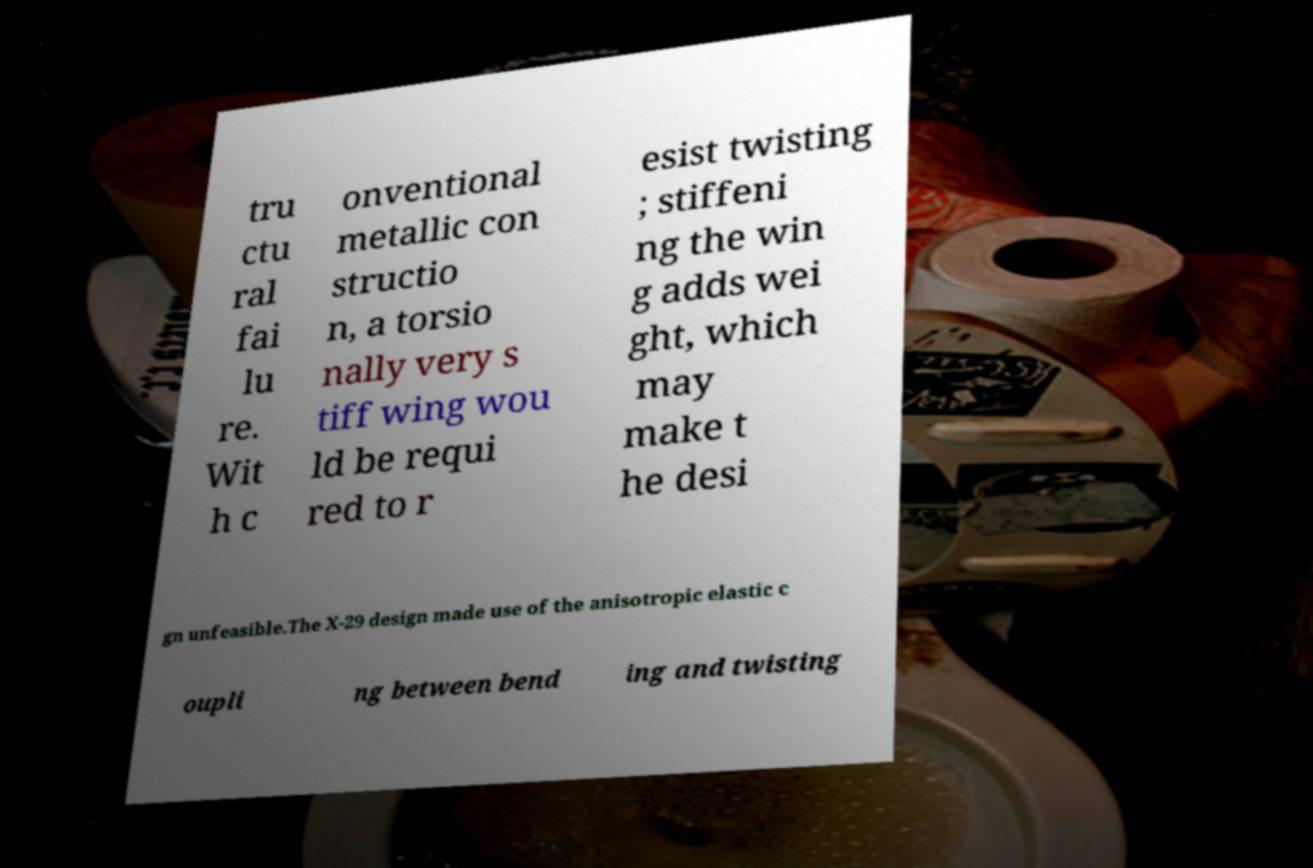What messages or text are displayed in this image? I need them in a readable, typed format. tru ctu ral fai lu re. Wit h c onventional metallic con structio n, a torsio nally very s tiff wing wou ld be requi red to r esist twisting ; stiffeni ng the win g adds wei ght, which may make t he desi gn unfeasible.The X-29 design made use of the anisotropic elastic c oupli ng between bend ing and twisting 